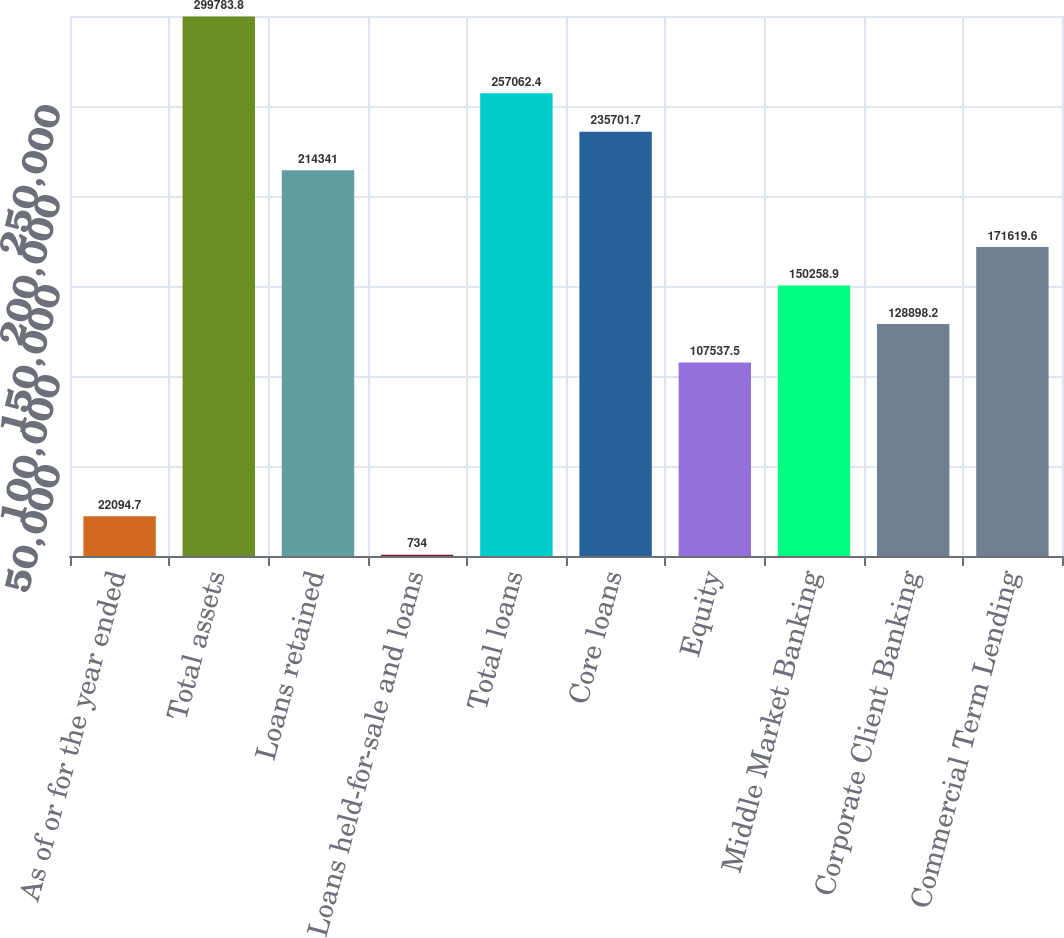Convert chart to OTSL. <chart><loc_0><loc_0><loc_500><loc_500><bar_chart><fcel>As of or for the year ended<fcel>Total assets<fcel>Loans retained<fcel>Loans held-for-sale and loans<fcel>Total loans<fcel>Core loans<fcel>Equity<fcel>Middle Market Banking<fcel>Corporate Client Banking<fcel>Commercial Term Lending<nl><fcel>22094.7<fcel>299784<fcel>214341<fcel>734<fcel>257062<fcel>235702<fcel>107538<fcel>150259<fcel>128898<fcel>171620<nl></chart> 